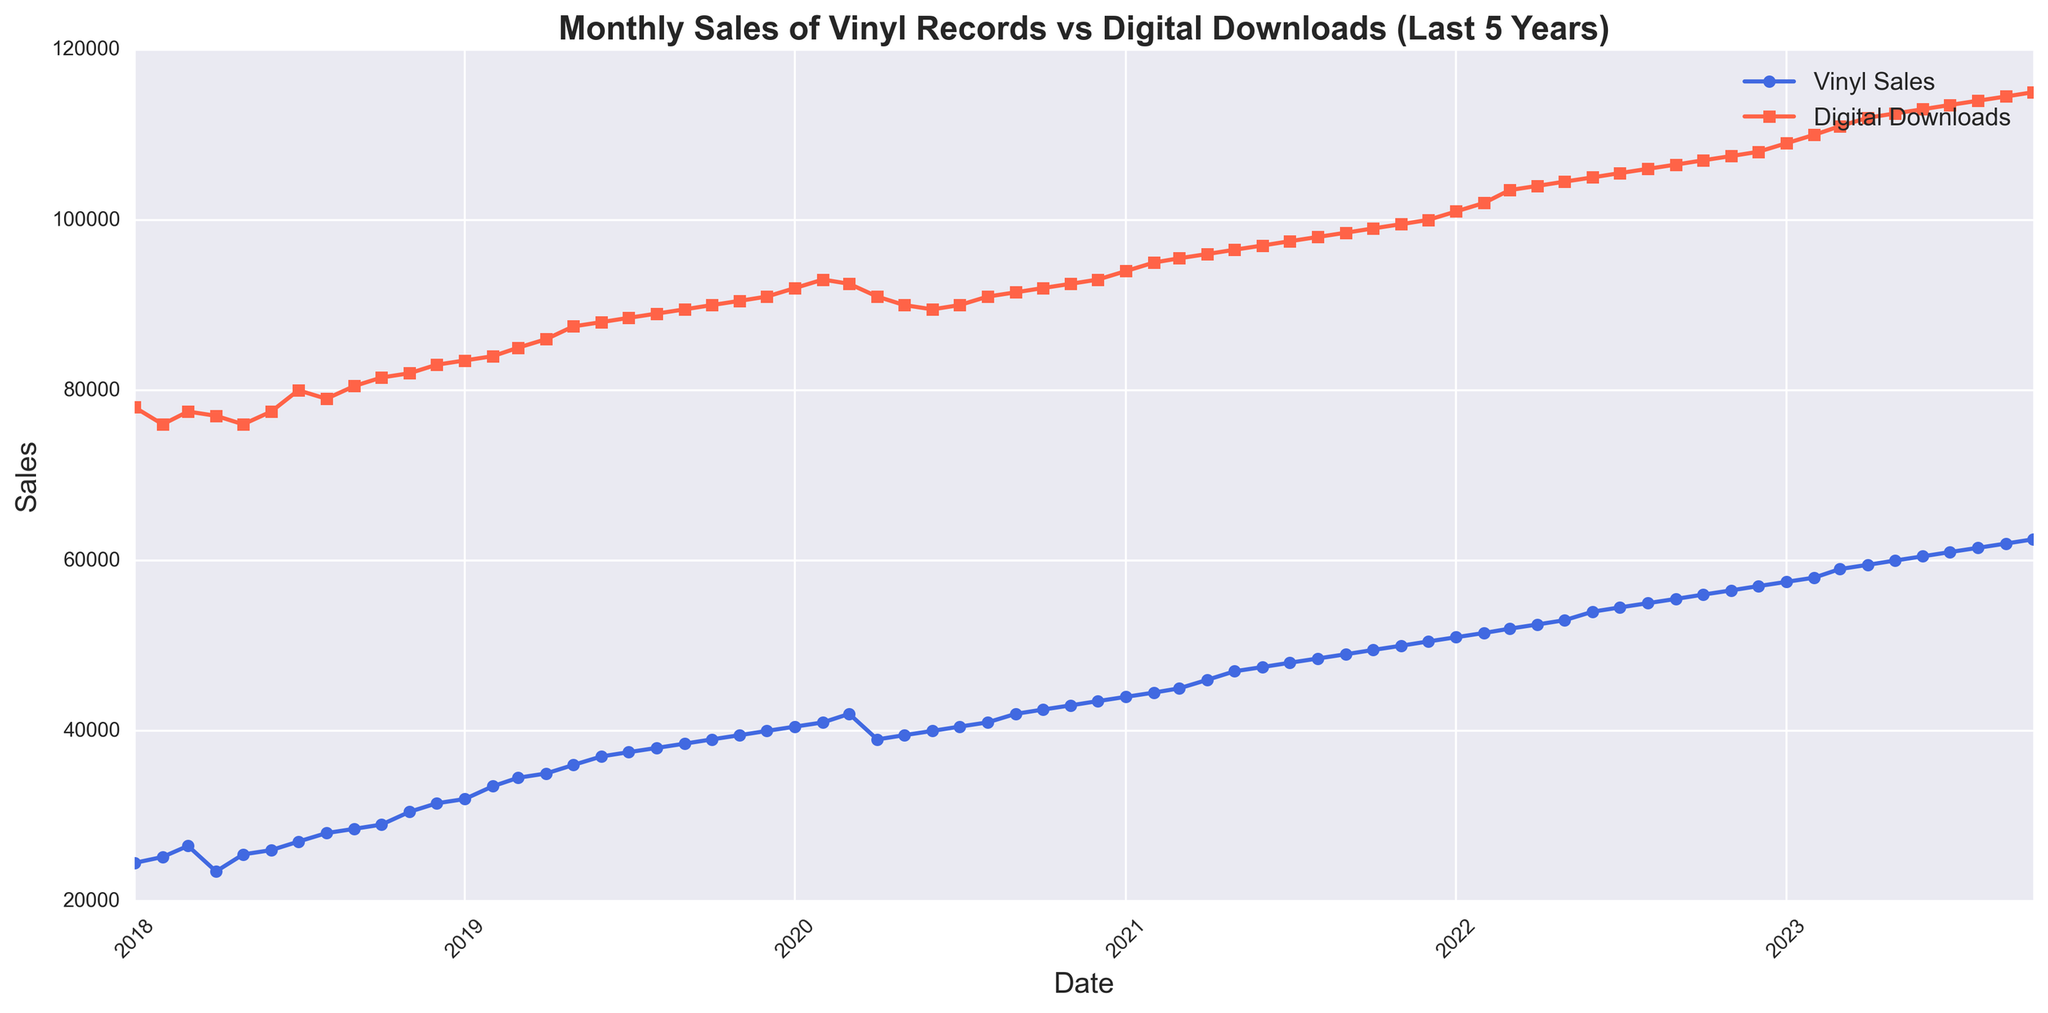What months show peaks or increases in Vinyl Sales and Digital Downloads over the last five years? By examining the figure, Vinyl Sales show notable peaks in December every year, while Digital Downloads consistently increase towards the end of the year, particularly in December.
Answer: December What was the sales level difference between Vinyl Records and Digital Downloads in December 2018? From the figure, in December 2018, the Vinyl Sales are approximately 31,500 units and Digital Downloads are around 83,000 units. The difference is calculated as 83,000 - 31,500.
Answer: 51,500 How did the sales trend for Vinyl Records change from January 2019 to December 2019? Looking at the visual trend line for Vinyl Sales from January 2019 to December 2019, the sales increased steadily over the year. January started at approximately 32,000 and by December, sales rose to around 40,000.
Answer: Increased steadily Which format had a higher rate of increase in sales from January 2018 to January 2023? To determine the rate of increase, compare the sales in January 2018 and January 2023 for both formats. Vinyl Sales increased from 24,500 to 57,500, and Digital Downloads increased from 78,000 to 109,000. The rate for Vinyl is greater as it more than doubled, whereas Digital Downloads did not.
Answer: Vinyl Records In which year did Vinyl Sales surpass 50,000 units for the first time? By examining the figure and noticing the trend, Vinyl Sales surpass the 50,000-unit threshold in the year 2021 for the first time, specifically looking at the data points where it happens.
Answer: 2021 How does the visual trend of Digital Downloads change during April 2020? The line representing Digital Downloads shows a slight dip in April 2020, indicating a minor drop in sales during that month compared to adjacent months.
Answer: Slight dip Comparing the sales in July 2018 and July 2022, what is the percentage increase in Vinyl Sales over these periods? In July 2018, Vinyl Sales are approximately 27,000. In July 2022, these increased to 54,500. The percentage increase is computed as ((54,500 - 27,000) / 27,000) * 100.
Answer: 101.85% Which format showed a more significant seasonal variation, and in which periods are these variations more apparent? The line for Vinyl Sales shows more significant seasonal variations, particularly with peaks in December of each year. Digital Downloads, while also showing peaks, have a more consistent upward trend.
Answer: Vinyl Sales in December What is the numerical difference in Digital Downloads between January 2021 and January 2023? Digital Downloads in January 2021 are approximately 94,000, and in January 2023, they are around 109,000. The difference between these numbers is calculated.
Answer: 15,000 